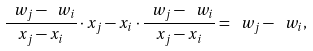Convert formula to latex. <formula><loc_0><loc_0><loc_500><loc_500>\frac { \ w _ { j } - \ w _ { i } } { x _ { j } - x _ { i } } \cdot x _ { j } - x _ { i } \cdot \frac { \ w _ { j } - \ w _ { i } } { x _ { j } - x _ { i } } = \ w _ { j } - \ w _ { i } ,</formula> 